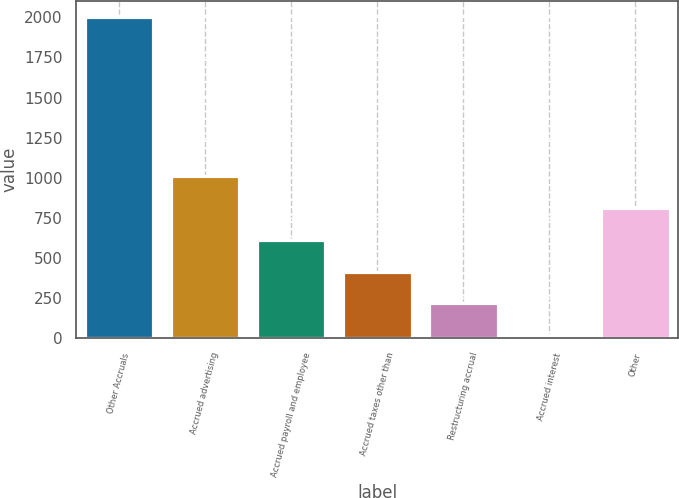Convert chart. <chart><loc_0><loc_0><loc_500><loc_500><bar_chart><fcel>Other Accruals<fcel>Accrued advertising<fcel>Accrued payroll and employee<fcel>Accrued taxes other than<fcel>Restructuring accrual<fcel>Accrued interest<fcel>Other<nl><fcel>2003<fcel>1011.35<fcel>614.69<fcel>416.36<fcel>218.03<fcel>19.7<fcel>813.02<nl></chart> 